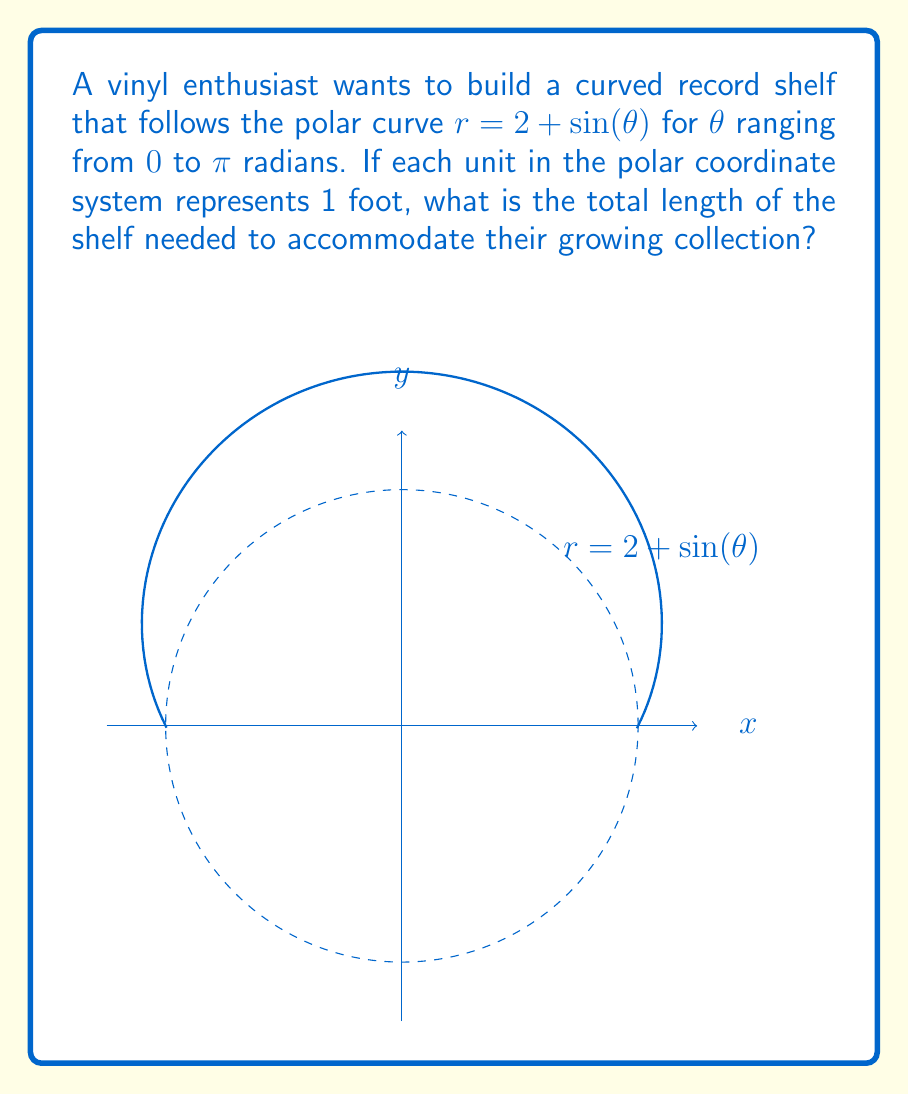What is the answer to this math problem? To find the length of the curved shelf, we need to use the arc length formula in polar coordinates:

$$ L = \int_a^b \sqrt{r^2 + \left(\frac{dr}{d\theta}\right)^2} d\theta $$

Given: $r = 2 + \sin(\theta)$, $\theta$ ranges from $0$ to $\pi$

Step 1: Find $\frac{dr}{d\theta}$
$$ \frac{dr}{d\theta} = \cos(\theta) $$

Step 2: Substitute into the arc length formula
$$ L = \int_0^\pi \sqrt{(2+\sin(\theta))^2 + (\cos(\theta))^2} d\theta $$

Step 3: Simplify the expression under the square root
$$ L = \int_0^\pi \sqrt{4 + 4\sin(\theta) + \sin^2(\theta) + \cos^2(\theta)} d\theta $$
$$ L = \int_0^\pi \sqrt{5 + 4\sin(\theta)} d\theta $$

Step 4: This integral cannot be evaluated analytically, so we need to use numerical integration methods. Using a computer algebra system or numerical integration tool, we can find:

$$ L \approx 7.640395 $$

Therefore, the length of the curved shelf is approximately 7.64 feet.
Answer: $7.64$ feet 